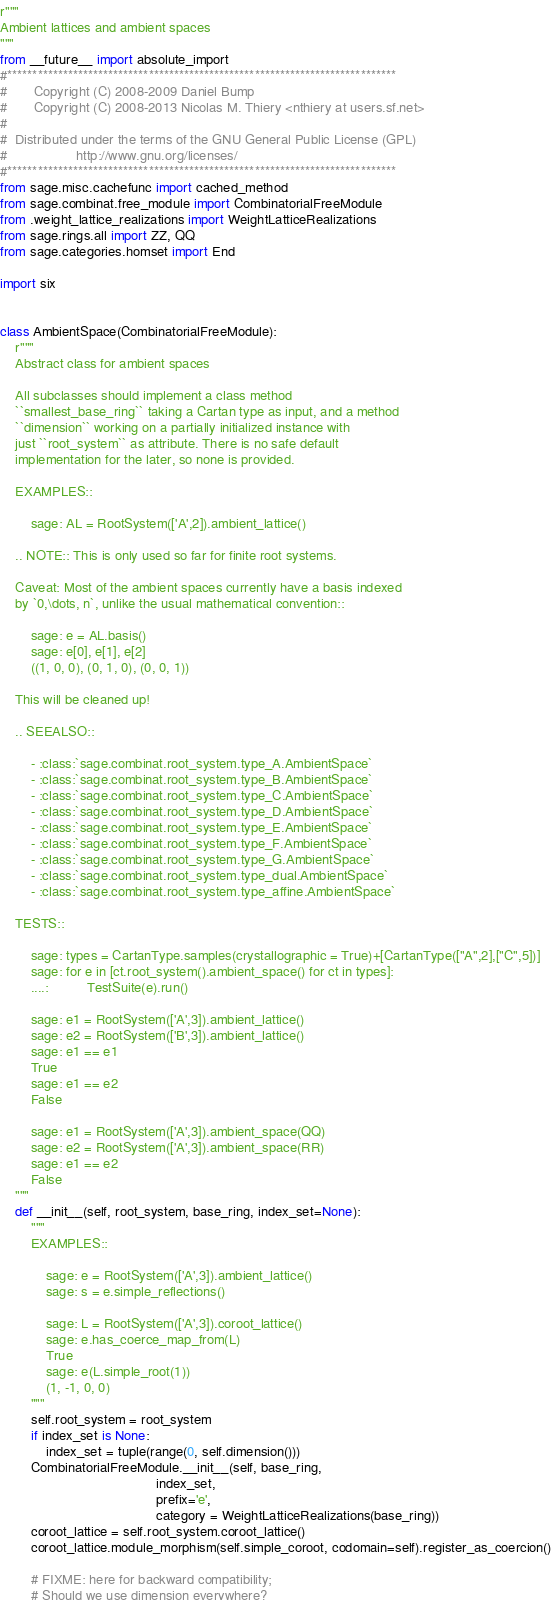Convert code to text. <code><loc_0><loc_0><loc_500><loc_500><_Python_>r"""
Ambient lattices and ambient spaces
"""
from __future__ import absolute_import
#*****************************************************************************
#       Copyright (C) 2008-2009 Daniel Bump
#       Copyright (C) 2008-2013 Nicolas M. Thiery <nthiery at users.sf.net>
#
#  Distributed under the terms of the GNU General Public License (GPL)
#                  http://www.gnu.org/licenses/
#*****************************************************************************
from sage.misc.cachefunc import cached_method
from sage.combinat.free_module import CombinatorialFreeModule
from .weight_lattice_realizations import WeightLatticeRealizations
from sage.rings.all import ZZ, QQ
from sage.categories.homset import End

import six


class AmbientSpace(CombinatorialFreeModule):
    r"""
    Abstract class for ambient spaces

    All subclasses should implement a class method
    ``smallest_base_ring`` taking a Cartan type as input, and a method
    ``dimension`` working on a partially initialized instance with
    just ``root_system`` as attribute. There is no safe default
    implementation for the later, so none is provided.

    EXAMPLES::

        sage: AL = RootSystem(['A',2]).ambient_lattice()

    .. NOTE:: This is only used so far for finite root systems.

    Caveat: Most of the ambient spaces currently have a basis indexed
    by `0,\dots, n`, unlike the usual mathematical convention::

        sage: e = AL.basis()
        sage: e[0], e[1], e[2]
        ((1, 0, 0), (0, 1, 0), (0, 0, 1))

    This will be cleaned up!

    .. SEEALSO::

        - :class:`sage.combinat.root_system.type_A.AmbientSpace`
        - :class:`sage.combinat.root_system.type_B.AmbientSpace`
        - :class:`sage.combinat.root_system.type_C.AmbientSpace`
        - :class:`sage.combinat.root_system.type_D.AmbientSpace`
        - :class:`sage.combinat.root_system.type_E.AmbientSpace`
        - :class:`sage.combinat.root_system.type_F.AmbientSpace`
        - :class:`sage.combinat.root_system.type_G.AmbientSpace`
        - :class:`sage.combinat.root_system.type_dual.AmbientSpace`
        - :class:`sage.combinat.root_system.type_affine.AmbientSpace`

    TESTS::

        sage: types = CartanType.samples(crystallographic = True)+[CartanType(["A",2],["C",5])]
        sage: for e in [ct.root_system().ambient_space() for ct in types]:
        ....:          TestSuite(e).run()

        sage: e1 = RootSystem(['A',3]).ambient_lattice()
        sage: e2 = RootSystem(['B',3]).ambient_lattice()
        sage: e1 == e1
        True
        sage: e1 == e2
        False

        sage: e1 = RootSystem(['A',3]).ambient_space(QQ)
        sage: e2 = RootSystem(['A',3]).ambient_space(RR)
        sage: e1 == e2
        False
    """
    def __init__(self, root_system, base_ring, index_set=None):
        """
        EXAMPLES::

            sage: e = RootSystem(['A',3]).ambient_lattice()
            sage: s = e.simple_reflections()

            sage: L = RootSystem(['A',3]).coroot_lattice()
            sage: e.has_coerce_map_from(L)
            True
            sage: e(L.simple_root(1))
            (1, -1, 0, 0)
        """
        self.root_system = root_system
        if index_set is None:
            index_set = tuple(range(0, self.dimension()))
        CombinatorialFreeModule.__init__(self, base_ring,
                                         index_set,
                                         prefix='e',
                                         category = WeightLatticeRealizations(base_ring))
        coroot_lattice = self.root_system.coroot_lattice()
        coroot_lattice.module_morphism(self.simple_coroot, codomain=self).register_as_coercion()

        # FIXME: here for backward compatibility;
        # Should we use dimension everywhere?</code> 